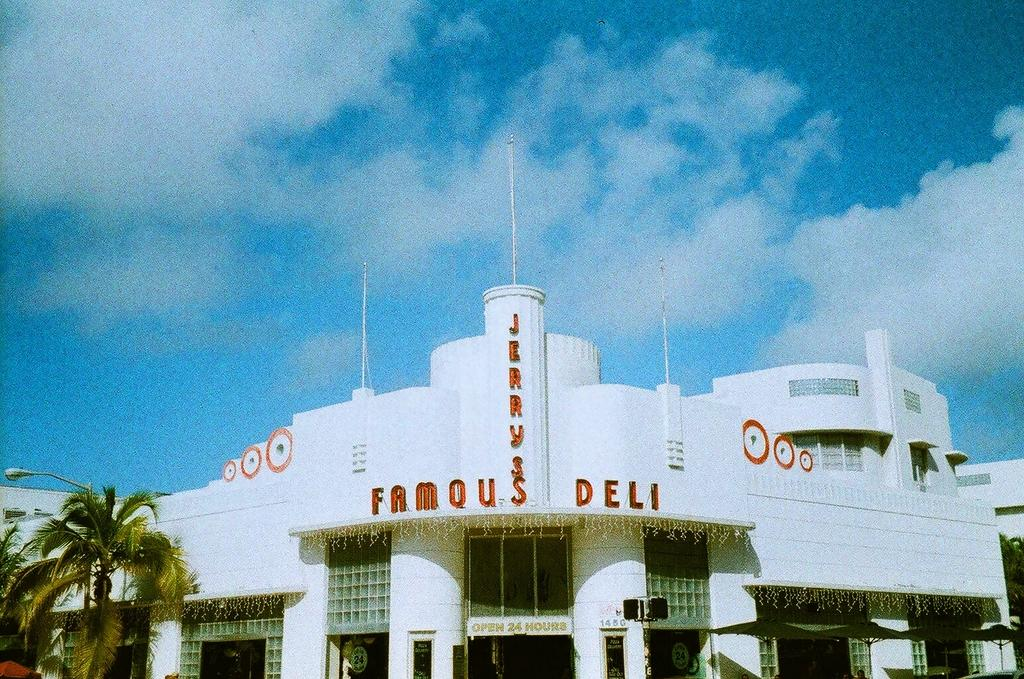<image>
Relay a brief, clear account of the picture shown. Jerry's Famous Deli has a bright white facade and palm trees outside. 